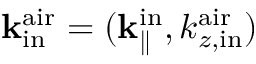Convert formula to latex. <formula><loc_0><loc_0><loc_500><loc_500>{ k } _ { i n } ^ { a i r } = ( { k } _ { \| } ^ { i n } , k _ { z , i n } ^ { a i r } )</formula> 